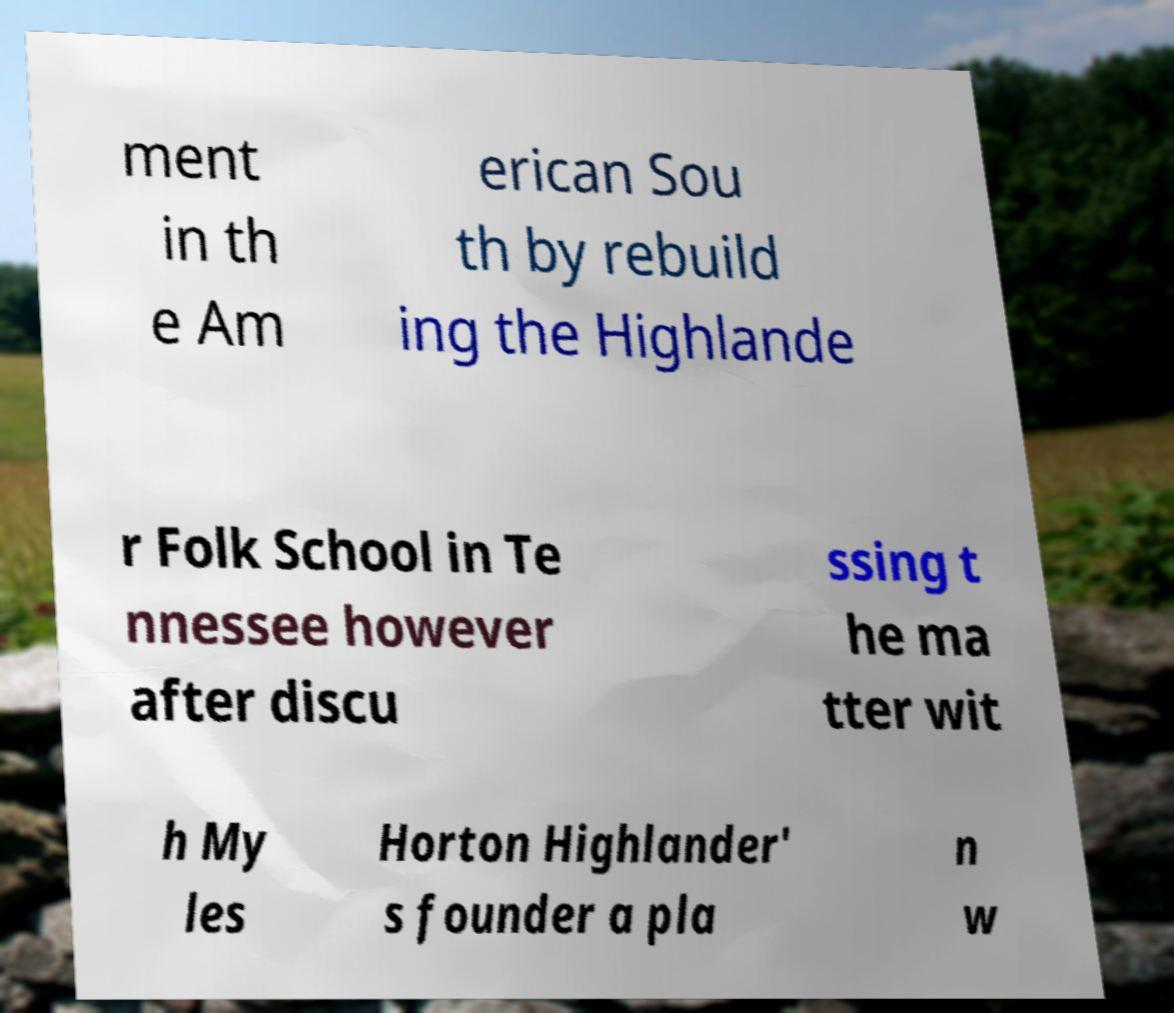What messages or text are displayed in this image? I need them in a readable, typed format. ment in th e Am erican Sou th by rebuild ing the Highlande r Folk School in Te nnessee however after discu ssing t he ma tter wit h My les Horton Highlander' s founder a pla n w 